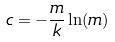Convert formula to latex. <formula><loc_0><loc_0><loc_500><loc_500>c = - \frac { m } { k } \ln ( m )</formula> 